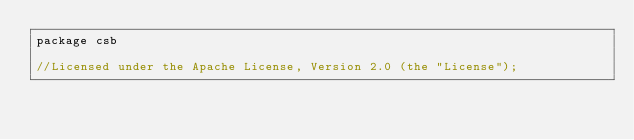<code> <loc_0><loc_0><loc_500><loc_500><_Go_>package csb

//Licensed under the Apache License, Version 2.0 (the "License");</code> 